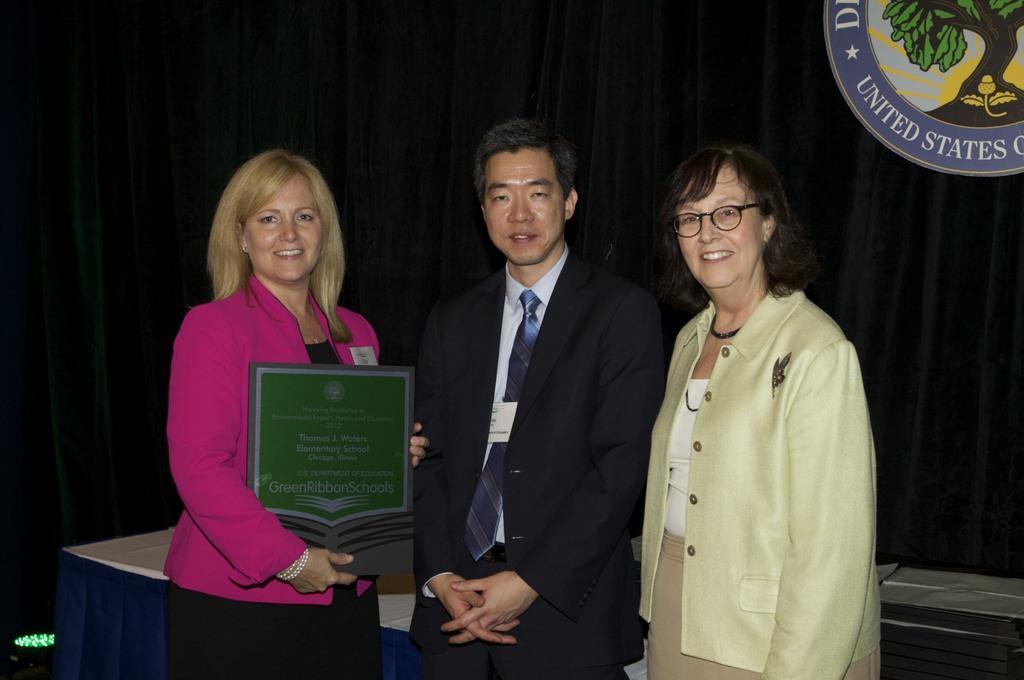Describe this image in one or two sentences. In this picture there are three people standing and smiling, among them there is a woman holding a board and we can see table and objects. In the background of the image we can see curtains, light and board. 